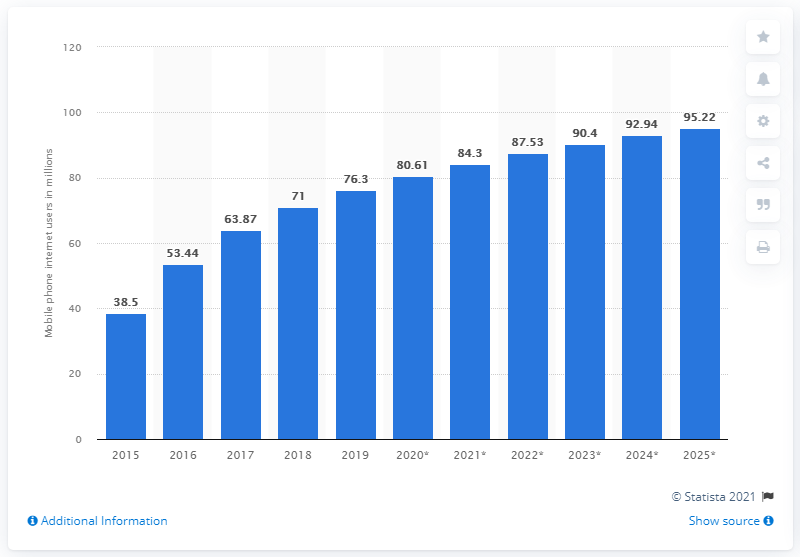Draw attention to some important aspects in this diagram. In 2015, there were 38.5 million mobile phone internet users in Mexico. By the end of 2020, it is projected that 80.61% of Mexican mobile phone users will access the internet. 